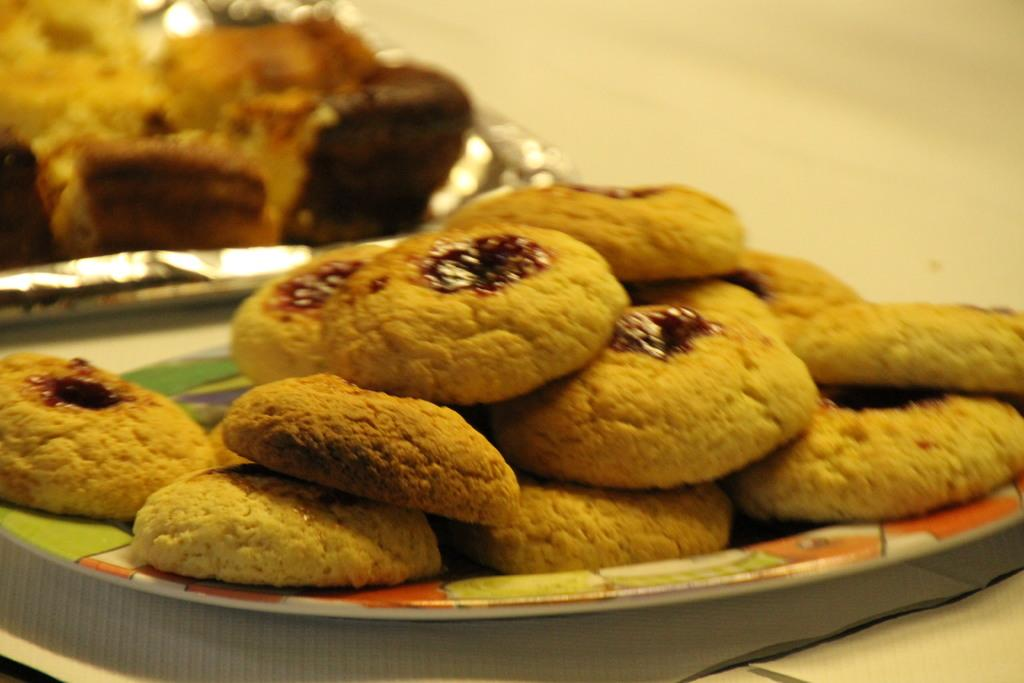What type of food can be seen on the plates in the image? There are cookies on plates in the image. What color is the background of the image? The background of the image is white. What is the profit margin of the cookies in the image? There is no information about the profit margin of the cookies in the image, as it is not related to the visual content. 